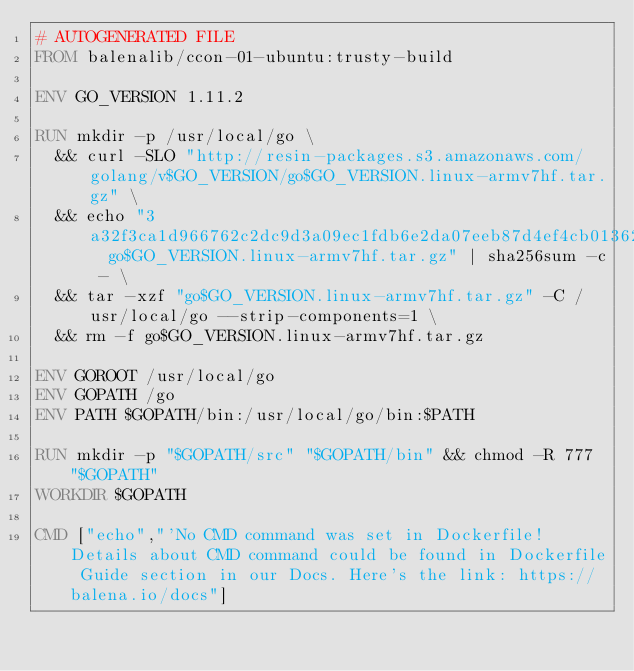Convert code to text. <code><loc_0><loc_0><loc_500><loc_500><_Dockerfile_># AUTOGENERATED FILE
FROM balenalib/ccon-01-ubuntu:trusty-build

ENV GO_VERSION 1.11.2

RUN mkdir -p /usr/local/go \
	&& curl -SLO "http://resin-packages.s3.amazonaws.com/golang/v$GO_VERSION/go$GO_VERSION.linux-armv7hf.tar.gz" \
	&& echo "3a32f3ca1d966762c2dc9d3a09ec1fdb6e2da07eeb87d4ef4cb01362f3fa9dc8  go$GO_VERSION.linux-armv7hf.tar.gz" | sha256sum -c - \
	&& tar -xzf "go$GO_VERSION.linux-armv7hf.tar.gz" -C /usr/local/go --strip-components=1 \
	&& rm -f go$GO_VERSION.linux-armv7hf.tar.gz

ENV GOROOT /usr/local/go
ENV GOPATH /go
ENV PATH $GOPATH/bin:/usr/local/go/bin:$PATH

RUN mkdir -p "$GOPATH/src" "$GOPATH/bin" && chmod -R 777 "$GOPATH"
WORKDIR $GOPATH

CMD ["echo","'No CMD command was set in Dockerfile! Details about CMD command could be found in Dockerfile Guide section in our Docs. Here's the link: https://balena.io/docs"]</code> 